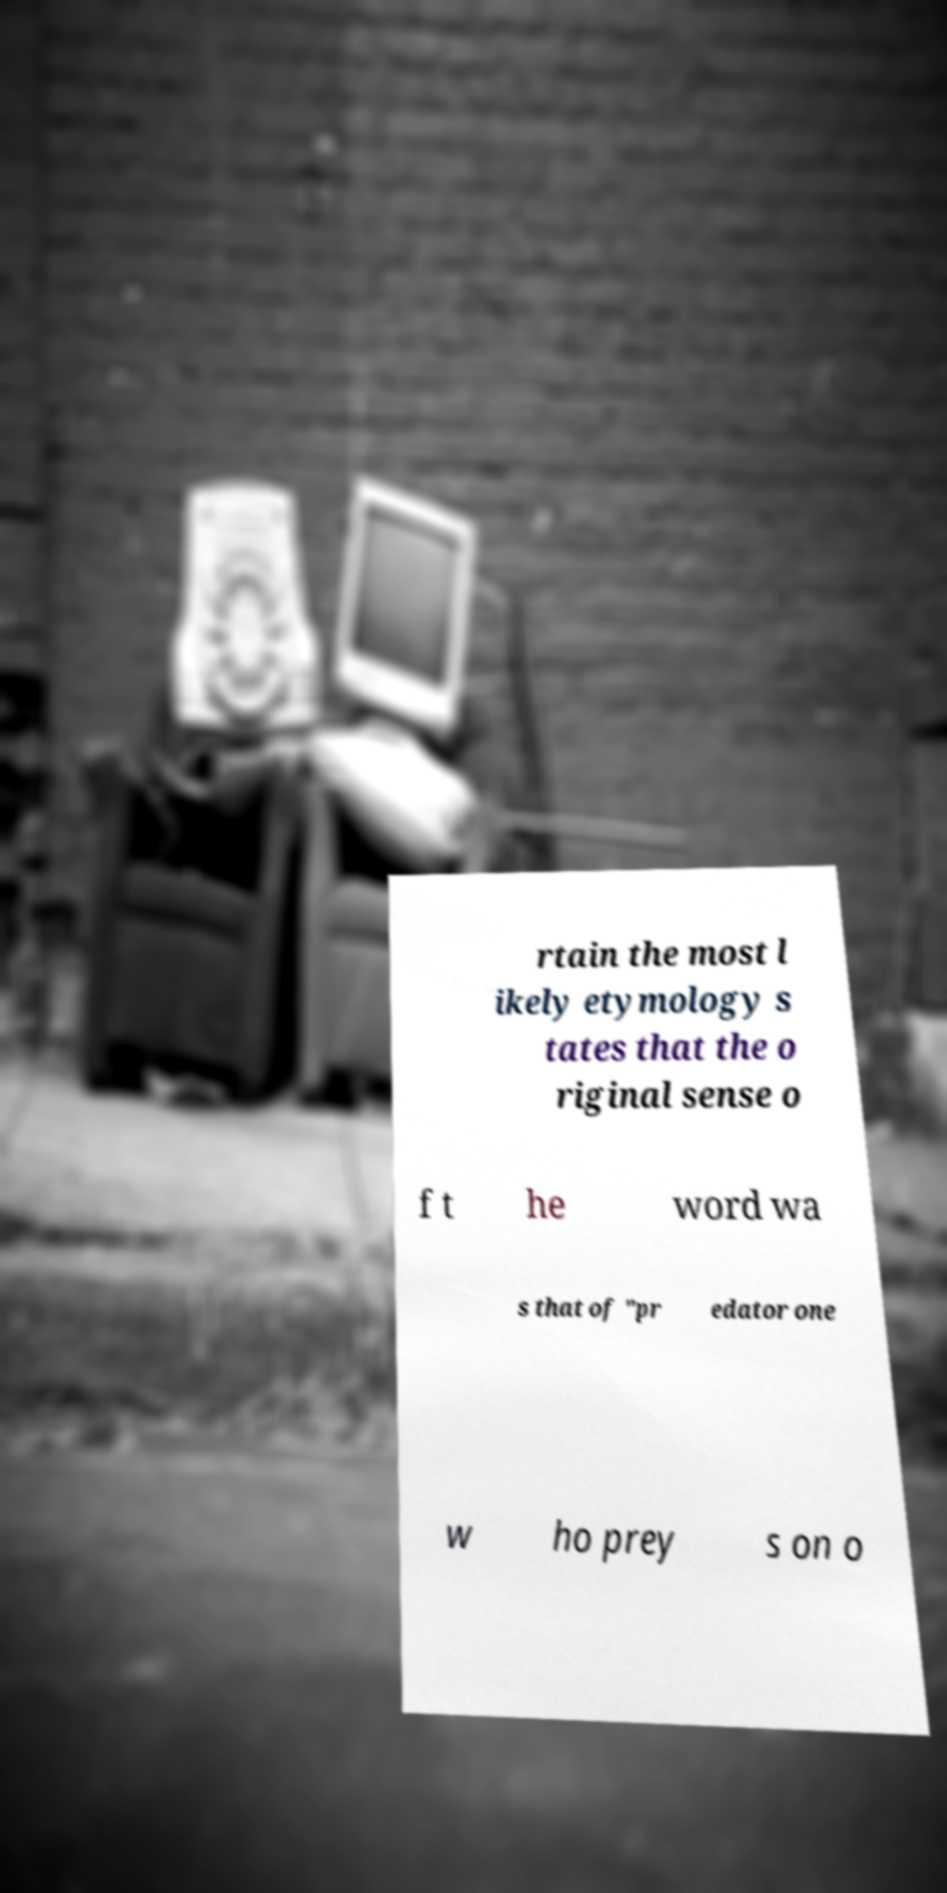Could you assist in decoding the text presented in this image and type it out clearly? rtain the most l ikely etymology s tates that the o riginal sense o f t he word wa s that of "pr edator one w ho prey s on o 